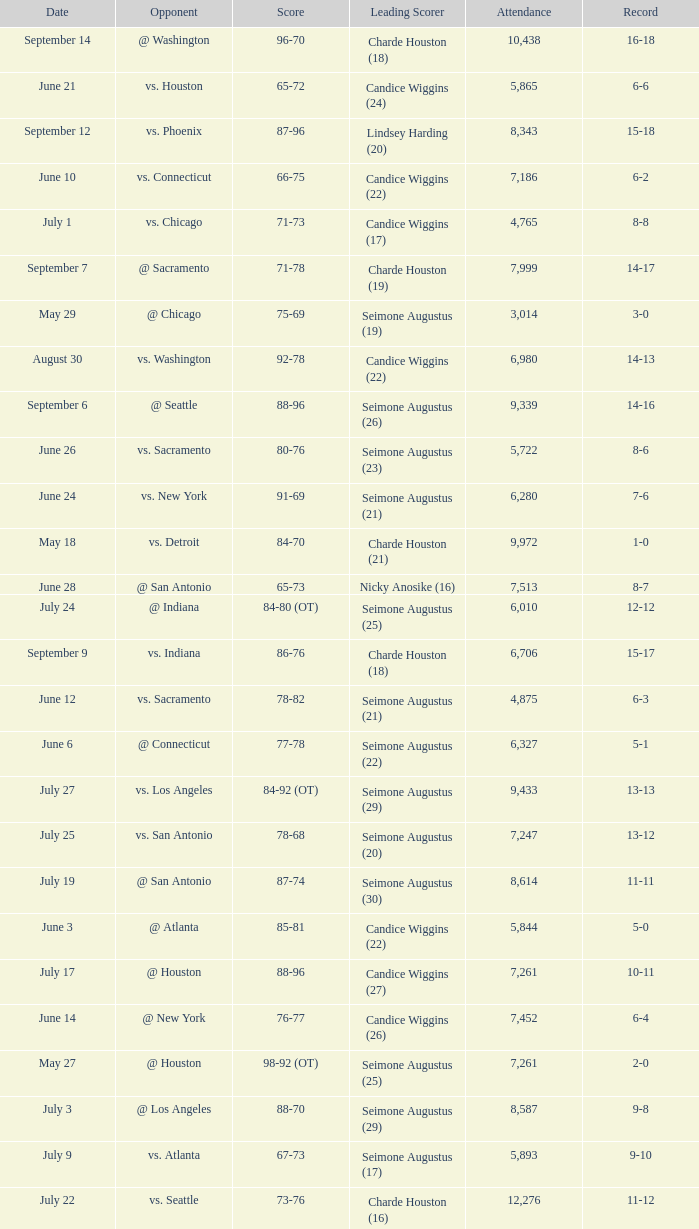Which Leading Scorer has an Opponent of @ seattle, and a Record of 14-16? Seimone Augustus (26). 